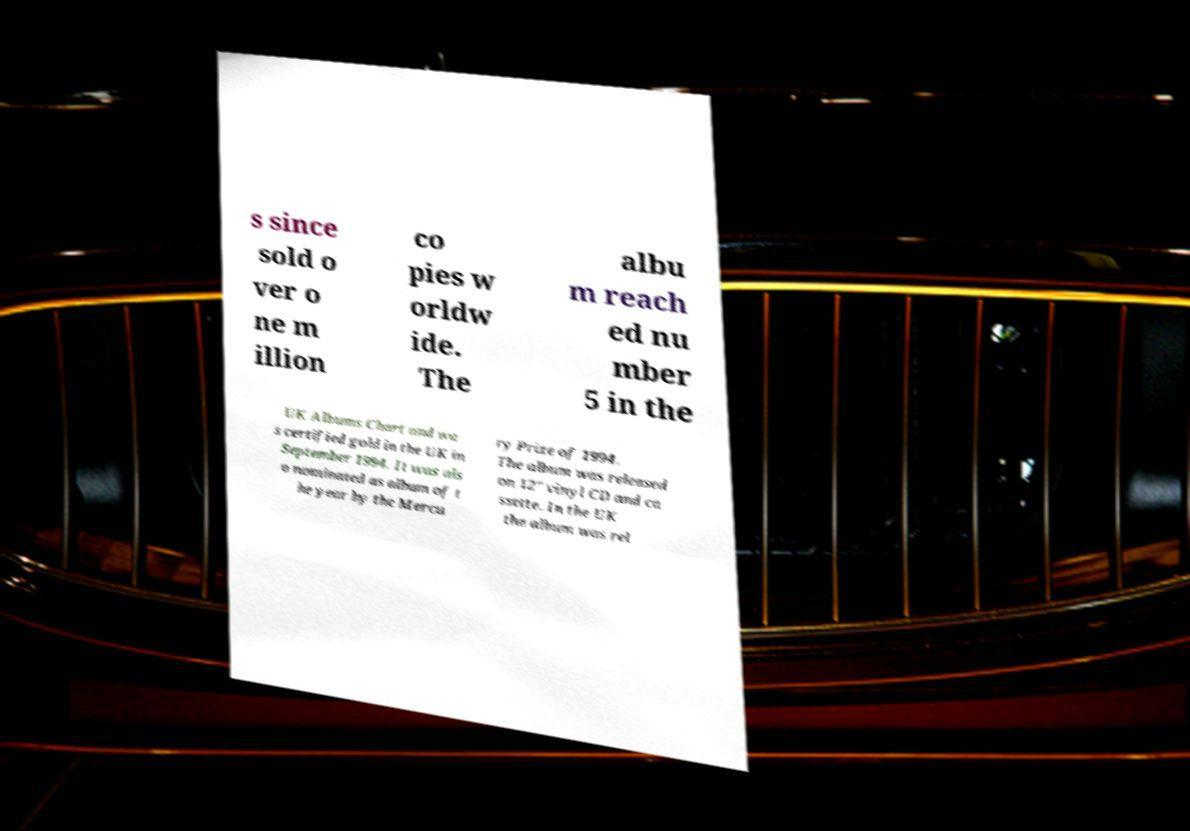I need the written content from this picture converted into text. Can you do that? s since sold o ver o ne m illion co pies w orldw ide. The albu m reach ed nu mber 5 in the UK Albums Chart and wa s certified gold in the UK in September 1994. It was als o nominated as album of t he year by the Mercu ry Prize of 1994. The album was released on 12" vinyl CD and ca ssette. In the UK the album was rel 